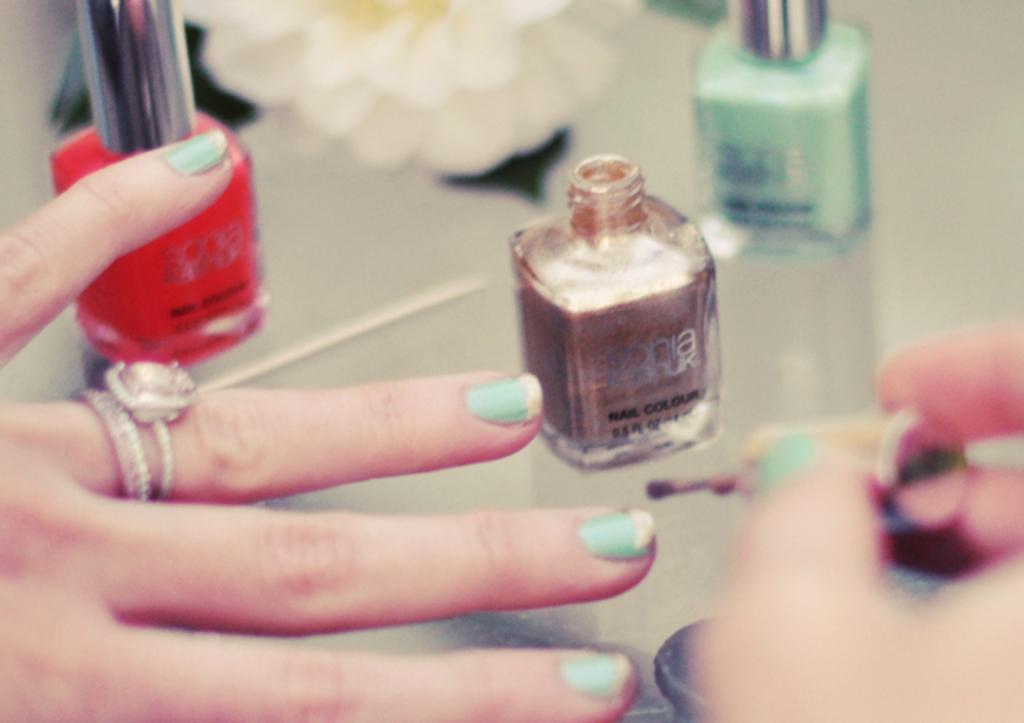<image>
Present a compact description of the photo's key features. A woman applies Sonia Kashuk nail color to her fingernails. 